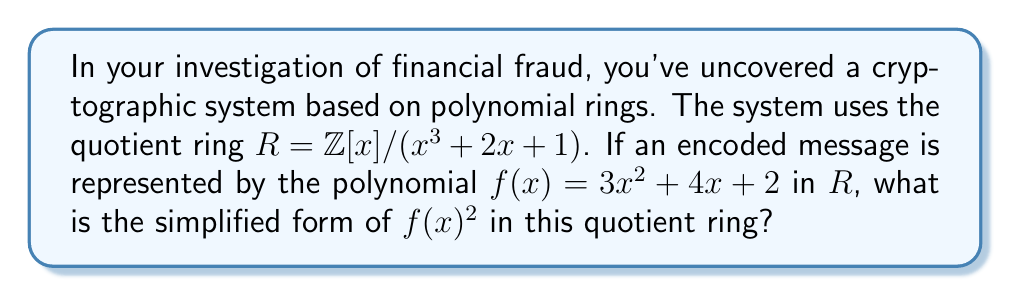Can you answer this question? To solve this problem, we need to follow these steps:

1) First, we calculate $f(x)^2$:
   $f(x)^2 = (3x^2 + 4x + 2)^2 = 9x^4 + 24x^3 + 22x^2 + 16x + 4$

2) In the quotient ring $R = \mathbb{Z}[x] / (x^3 + 2x + 1)$, we have the relation $x^3 \equiv -2x - 1 \pmod{x^3 + 2x + 1}$

3) We use this to reduce the degree of our polynomial:
   $9x^4 + 24x^3 + 22x^2 + 16x + 4$
   $\equiv 9x(x^3) + 24x^3 + 22x^2 + 16x + 4$
   $\equiv 9x(-2x - 1) + 24x^3 + 22x^2 + 16x + 4$
   $\equiv -18x^2 - 9x + 24x^3 + 22x^2 + 16x + 4$

4) We apply the reduction again to $24x^3$:
   $\equiv -18x^2 - 9x + 24(-2x - 1) + 22x^2 + 16x + 4$
   $\equiv -18x^2 - 9x - 48x - 24 + 22x^2 + 16x + 4$
   $\equiv 4x^2 - 41x - 20$

5) This polynomial is now in its reduced form in $R$, as its degree is less than 3.
Answer: $f(x)^2 \equiv 4x^2 - 41x - 20 \pmod{x^3 + 2x + 1}$ 